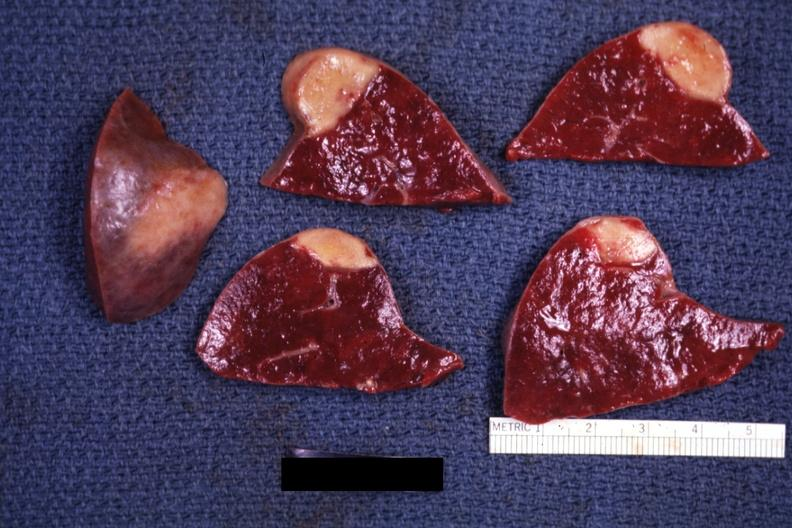does this image show several slices with obvious lesion and one external view excellent example?
Answer the question using a single word or phrase. Yes 